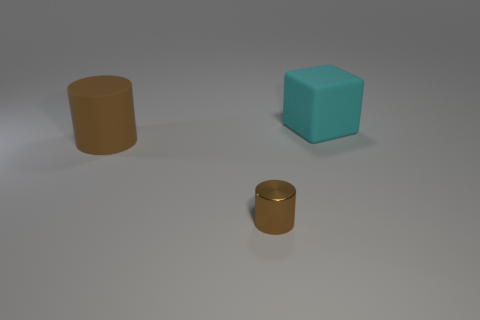Add 3 small metal cylinders. How many objects exist? 6 Subtract all cylinders. How many objects are left? 1 Add 1 tiny things. How many tiny things are left? 2 Add 2 brown metallic cylinders. How many brown metallic cylinders exist? 3 Subtract 0 gray cubes. How many objects are left? 3 Subtract all small green metal balls. Subtract all brown things. How many objects are left? 1 